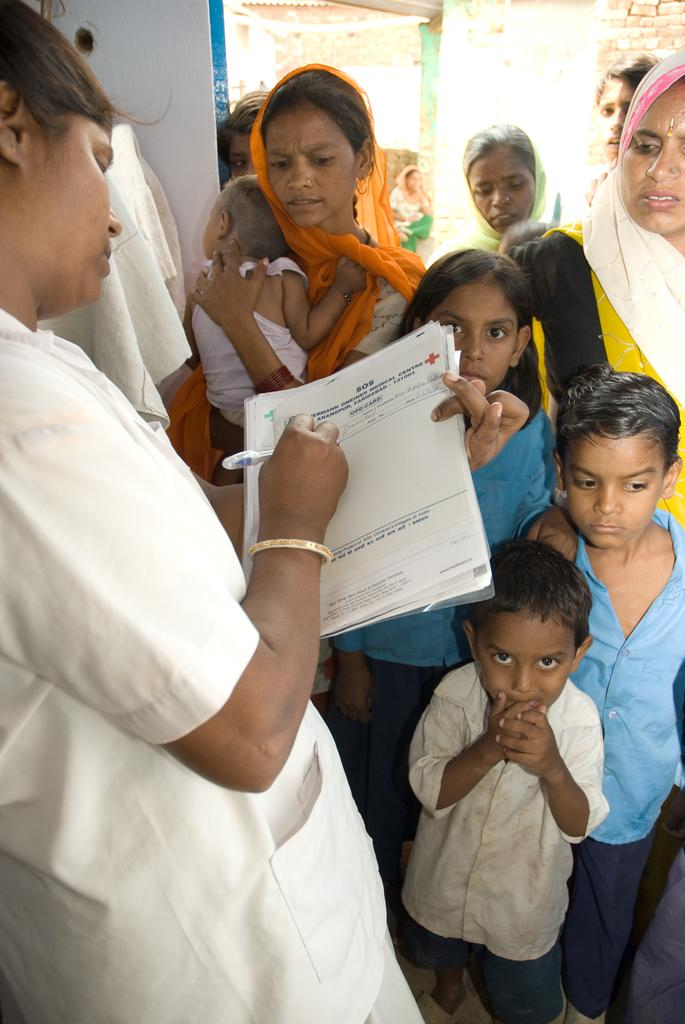Who is the main subject in the image? There is a woman in the image. What is the woman wearing? The woman is wearing a doctor's apron. What is the woman doing in the image? The woman is writing a prescription. Where is the prescription located in the image? The prescription is on the left side of the image. What can be seen in the front of the image? There are many kids and at least one woman standing in the front of the image. How many chairs are visible in the image? There is no mention of chairs in the provided facts, so we cannot determine the number of chairs in the image. 